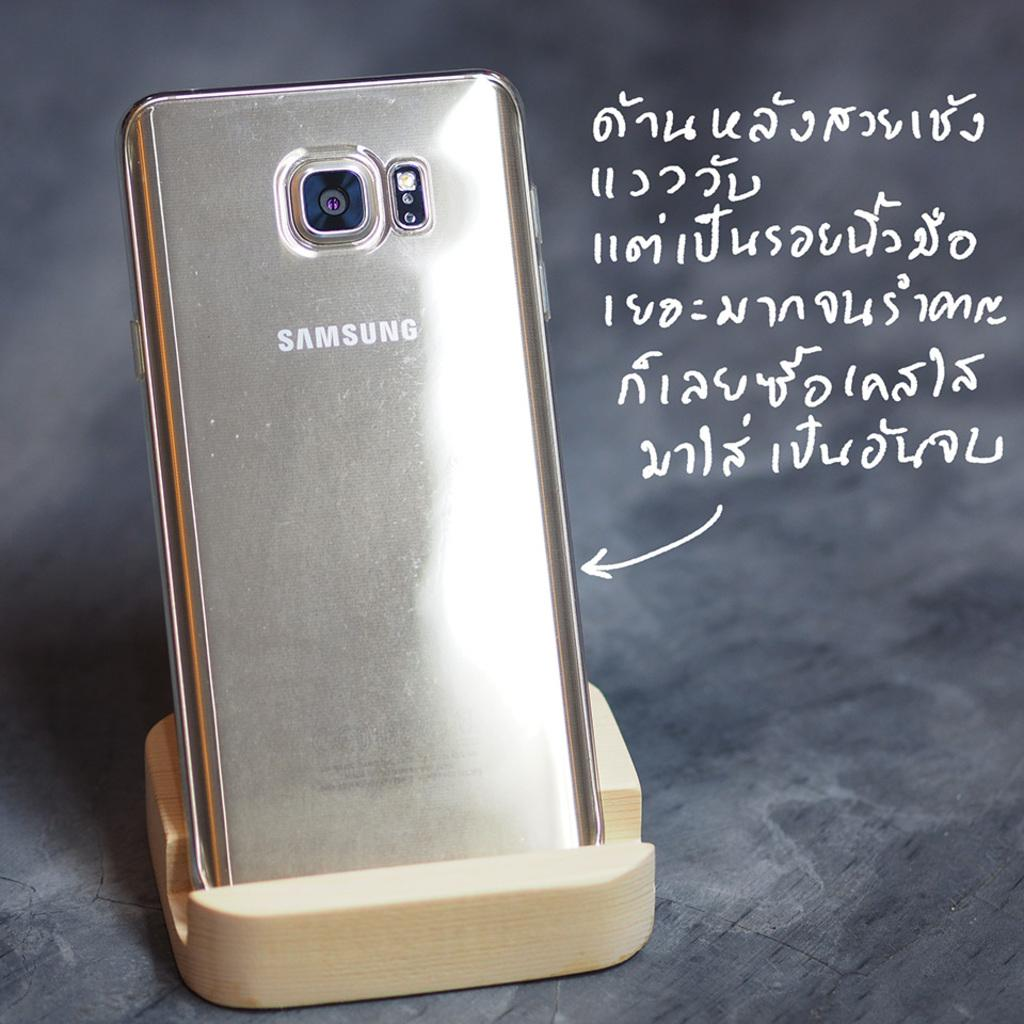<image>
Write a terse but informative summary of the picture. A Samsung phone sits upright in a holder with words in another language pointing to it. 